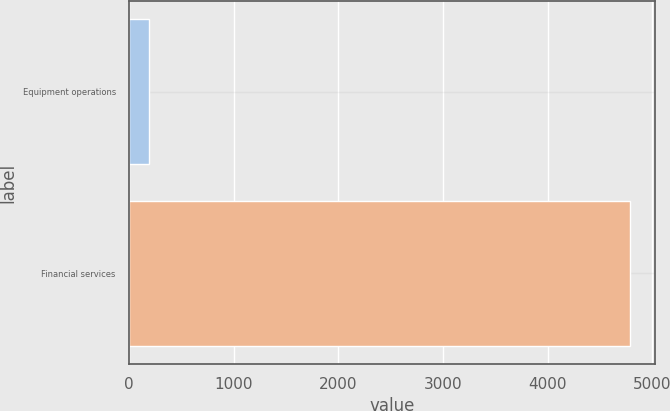<chart> <loc_0><loc_0><loc_500><loc_500><bar_chart><fcel>Equipment operations<fcel>Financial services<nl><fcel>195<fcel>4790<nl></chart> 